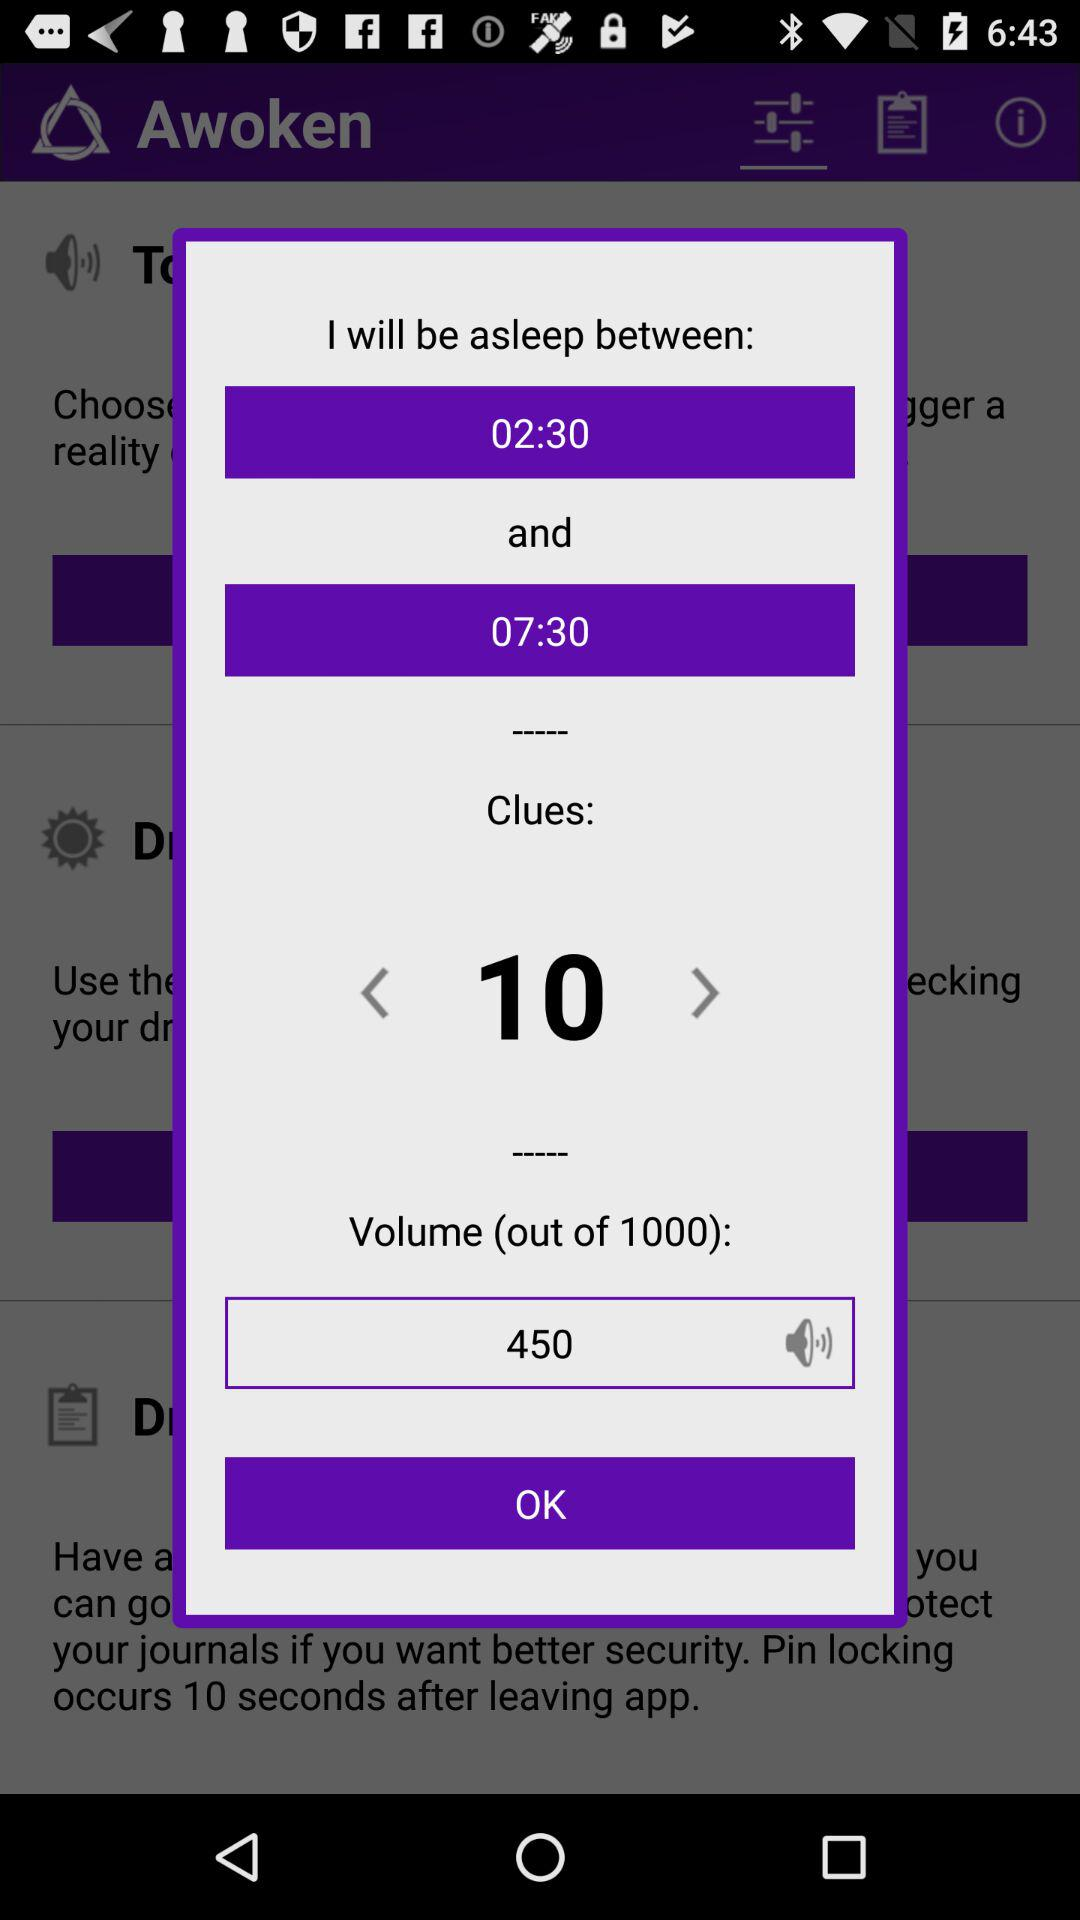What is the asleep time? The asleep time is between 02:30 and 07:30. 